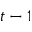<formula> <loc_0><loc_0><loc_500><loc_500>t - 1</formula> 